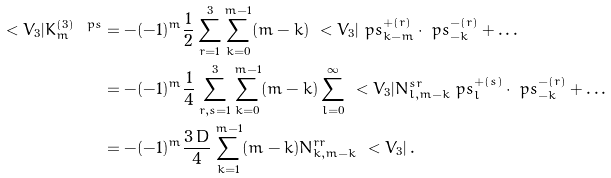Convert formula to latex. <formula><loc_0><loc_0><loc_500><loc_500>\ < V _ { 3 } | K _ { m } ^ { ( 3 ) \ p s } & = - ( - 1 ) ^ { m } \frac { 1 } { 2 } \sum _ { r = 1 } ^ { 3 } \sum _ { k = 0 } ^ { m - 1 } ( m - k ) \ < V _ { 3 } | \ p s _ { k - m } ^ { + ( r ) } \cdot \ p s _ { - k } ^ { - ( r ) } + \dots \\ & = - ( - 1 ) ^ { m } \frac { 1 } { 4 } \sum _ { r , s = 1 } ^ { 3 } \sum _ { k = 0 } ^ { m - 1 } ( m - k ) \sum _ { l = 0 } ^ { \infty } \ < V _ { 3 } | N ^ { s r } _ { l , m - k } \ p s _ { l } ^ { + ( s ) } \cdot \ p s _ { - k } ^ { - ( r ) } + \dots \\ & = - ( - 1 ) ^ { m } \frac { 3 \, D } { 4 } \sum _ { k = 1 } ^ { m - 1 } ( m - k ) N ^ { r r } _ { k , m - k } \ < V _ { 3 } | \, .</formula> 